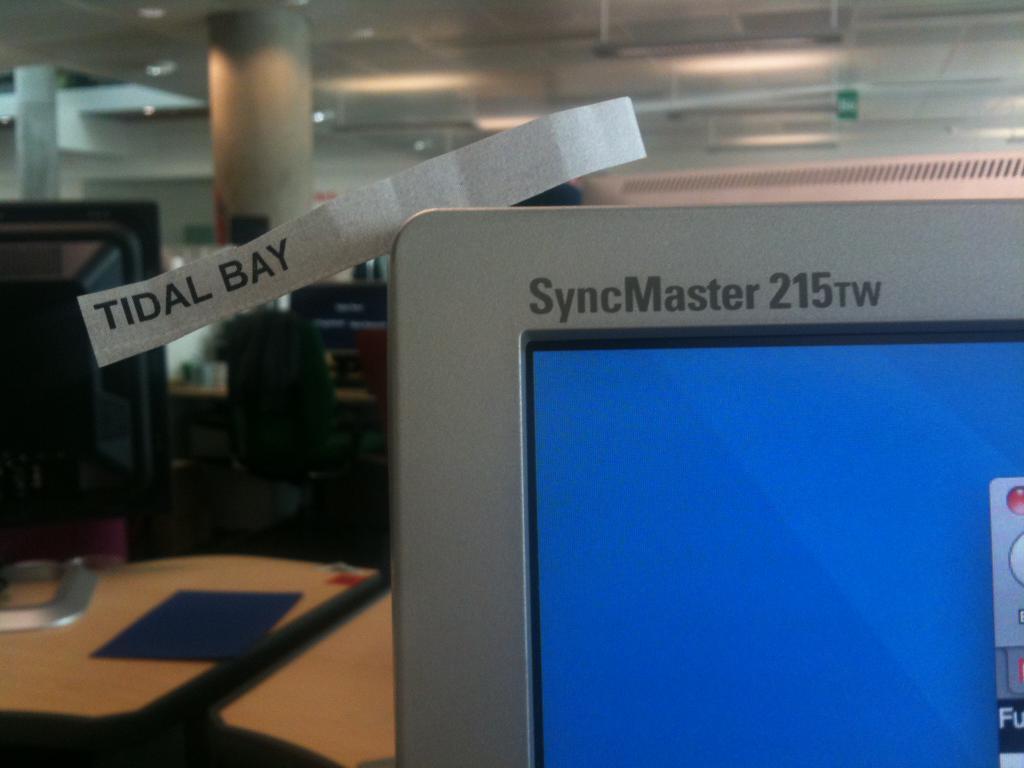What model type is this monitor?
Offer a terse response. Syncmaster 215tw. What is printed on the top left corner of the monitor in this photo?
Your answer should be very brief. Tidal bay. 